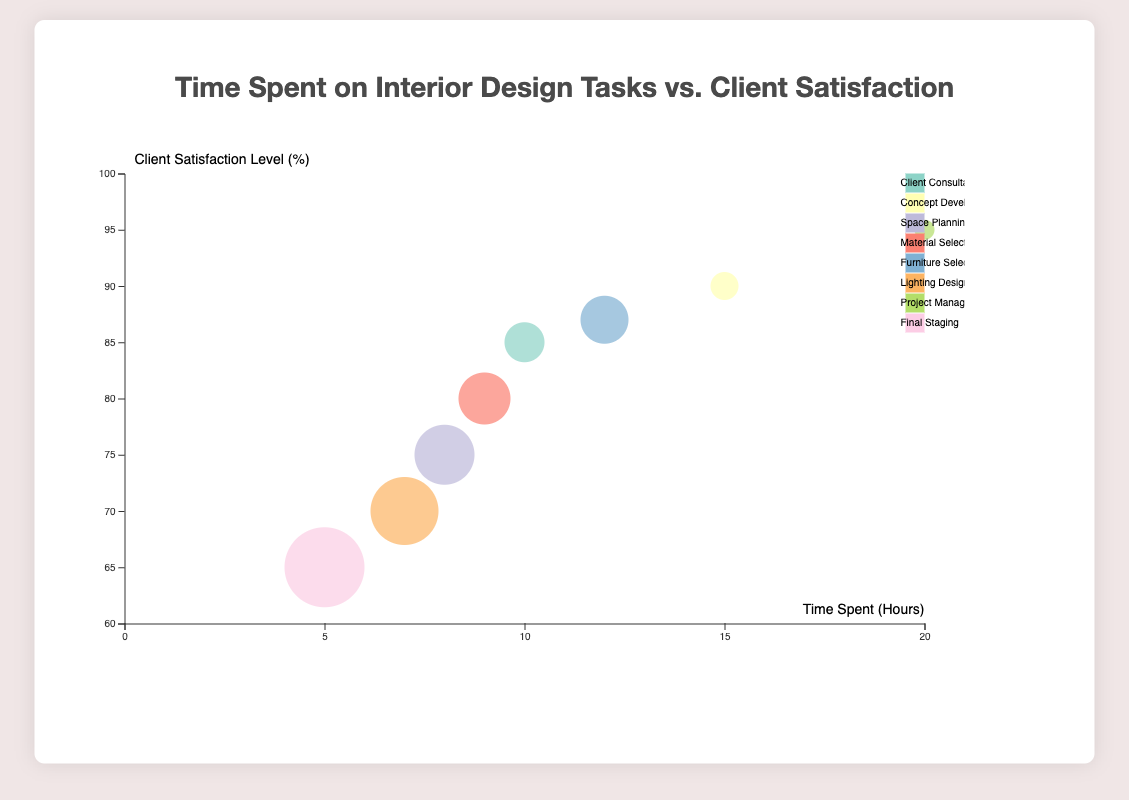How many tasks are displayed in the bubble chart? There are one bubble for each task. Counting the bubbles or legend will give the total number of tasks.
Answer: 8 Which task has the highest client satisfaction level? Locate the bubble with the highest position on the vertical axis, which represents the client satisfaction level.
Answer: Project Management What is the time spent on "Concept Development"? Identify the bubble labeled "Concept Development," then look at the horizontal position to find the time spent.
Answer: 15 hours How many clients were involved in "Lighting Design"? Find the bubble corresponding to "Lighting Design," and refer to the size of the bubble. The size indicates the number of clients.
Answer: 22 Which task has the lowest client satisfaction level? Locate the bubble with the lowest position on the vertical axis to find the task with the lowest client satisfaction level.
Answer: Final Staging Compare the time spent on "Material Selection" and "Lighting Design". Which task took more time? Locate the bubbles for both tasks and compare their horizontal positions to determine which bubble is further to the right.
Answer: Material Selection What is the average client satisfaction level across all tasks? Sum all client satisfaction levels and divide by the number of tasks: (85 + 90 + 75 + 80 + 87 + 70 + 95 + 65) / 8.
Answer: 80.88% Which task involved the greatest number of clients? Identify the largest bubble in the chart, which represents the task with the greatest number of clients.
Answer: Final Staging How much more time is spent on "Project Management" compared to "Final Staging"? Subtract the time spent on "Final Staging" from the time spent on "Project Management": 20 - 5.
Answer: 15 hours 